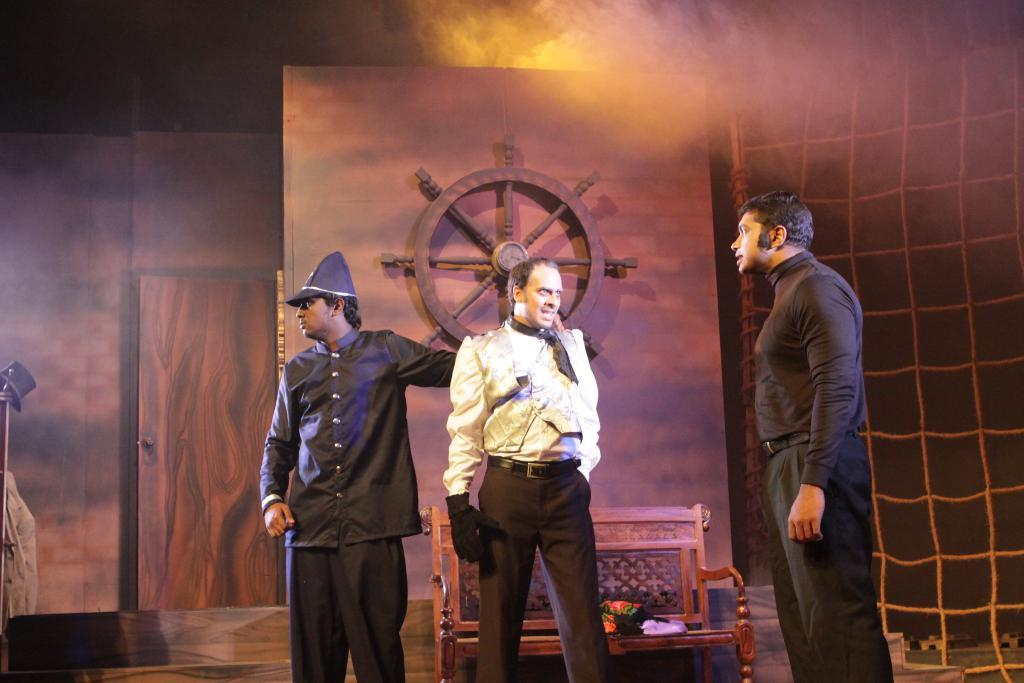How many people are present in the image? There are three people standing in the image. What can be seen in the background of the image? There is a bench, a wall, a door, a showpiece, and a hat in the background of the image. What is placed on the bench in the background? There are objects placed on the bench in the background. What type of sofa can be seen in the image? There is no sofa present in the image. How long does it take for the minute to pass in the image? Time cannot be measured in an image, as it is a still representation of a scene. 